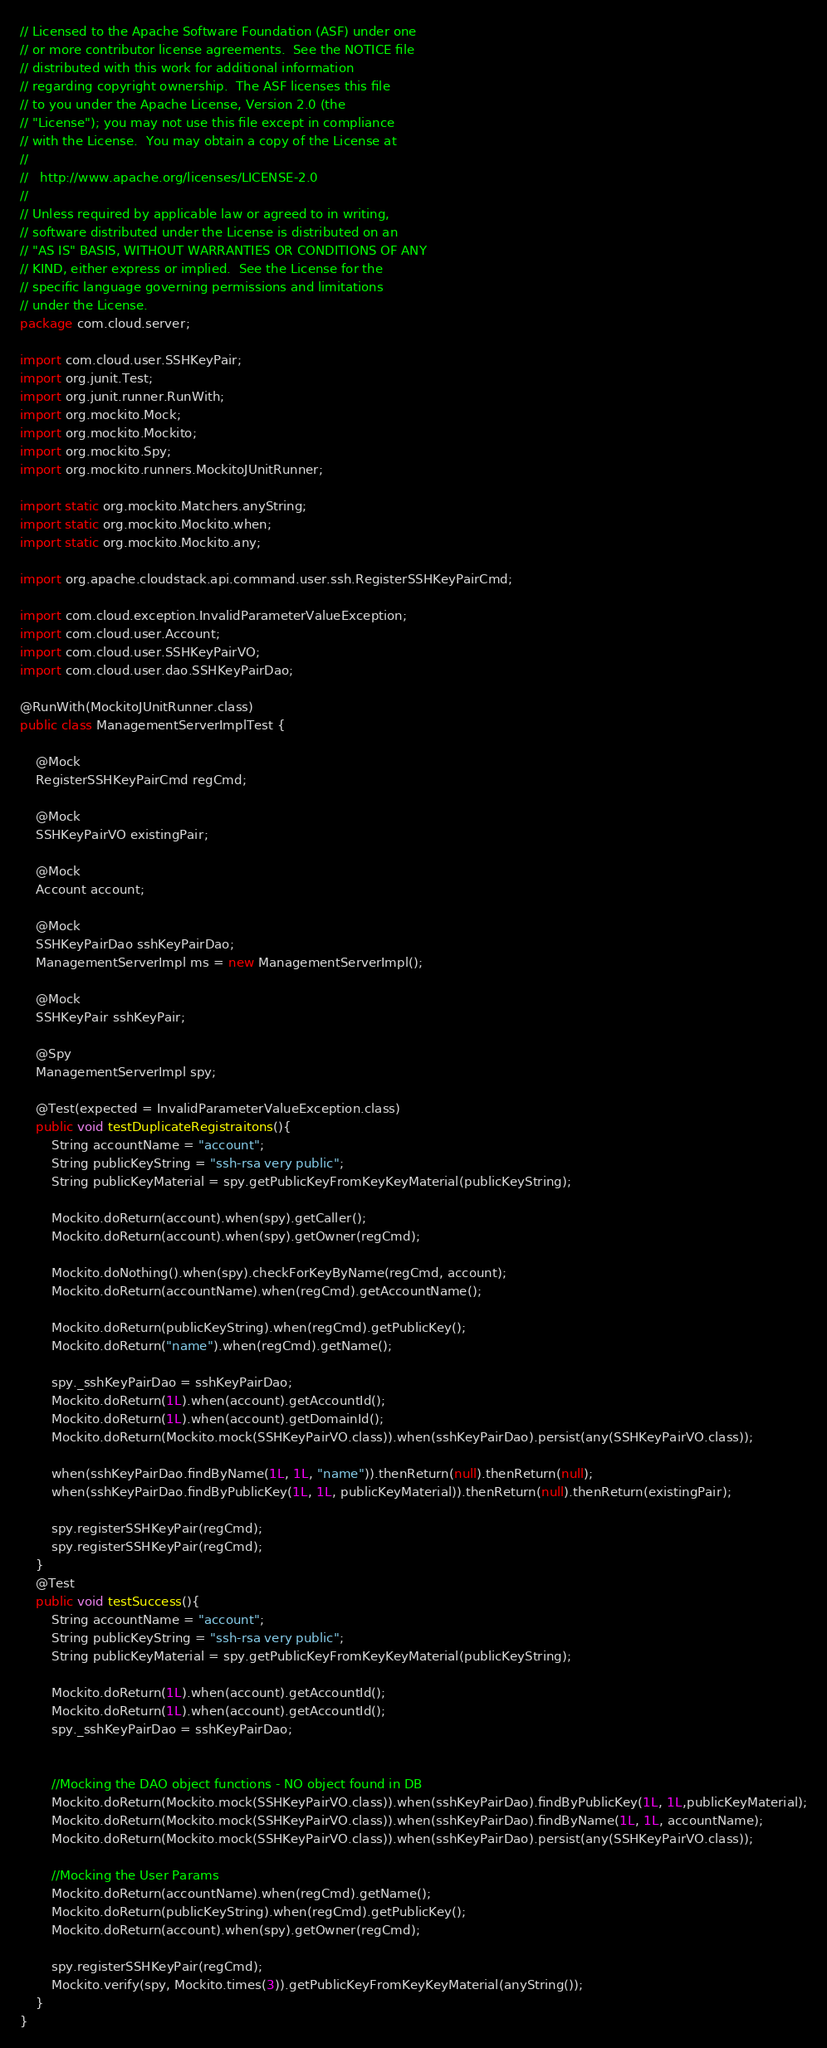Convert code to text. <code><loc_0><loc_0><loc_500><loc_500><_Java_>// Licensed to the Apache Software Foundation (ASF) under one
// or more contributor license agreements.  See the NOTICE file
// distributed with this work for additional information
// regarding copyright ownership.  The ASF licenses this file
// to you under the Apache License, Version 2.0 (the
// "License"); you may not use this file except in compliance
// with the License.  You may obtain a copy of the License at
//
//   http://www.apache.org/licenses/LICENSE-2.0
//
// Unless required by applicable law or agreed to in writing,
// software distributed under the License is distributed on an
// "AS IS" BASIS, WITHOUT WARRANTIES OR CONDITIONS OF ANY
// KIND, either express or implied.  See the License for the
// specific language governing permissions and limitations
// under the License.
package com.cloud.server;

import com.cloud.user.SSHKeyPair;
import org.junit.Test;
import org.junit.runner.RunWith;
import org.mockito.Mock;
import org.mockito.Mockito;
import org.mockito.Spy;
import org.mockito.runners.MockitoJUnitRunner;

import static org.mockito.Matchers.anyString;
import static org.mockito.Mockito.when;
import static org.mockito.Mockito.any;

import org.apache.cloudstack.api.command.user.ssh.RegisterSSHKeyPairCmd;

import com.cloud.exception.InvalidParameterValueException;
import com.cloud.user.Account;
import com.cloud.user.SSHKeyPairVO;
import com.cloud.user.dao.SSHKeyPairDao;

@RunWith(MockitoJUnitRunner.class)
public class ManagementServerImplTest {

    @Mock
    RegisterSSHKeyPairCmd regCmd;

    @Mock
    SSHKeyPairVO existingPair;

    @Mock
    Account account;

    @Mock
    SSHKeyPairDao sshKeyPairDao;
    ManagementServerImpl ms = new ManagementServerImpl();

    @Mock
    SSHKeyPair sshKeyPair;

    @Spy
    ManagementServerImpl spy;

    @Test(expected = InvalidParameterValueException.class)
    public void testDuplicateRegistraitons(){
        String accountName = "account";
        String publicKeyString = "ssh-rsa very public";
        String publicKeyMaterial = spy.getPublicKeyFromKeyKeyMaterial(publicKeyString);

        Mockito.doReturn(account).when(spy).getCaller();
        Mockito.doReturn(account).when(spy).getOwner(regCmd);

        Mockito.doNothing().when(spy).checkForKeyByName(regCmd, account);
        Mockito.doReturn(accountName).when(regCmd).getAccountName();

        Mockito.doReturn(publicKeyString).when(regCmd).getPublicKey();
        Mockito.doReturn("name").when(regCmd).getName();

        spy._sshKeyPairDao = sshKeyPairDao;
        Mockito.doReturn(1L).when(account).getAccountId();
        Mockito.doReturn(1L).when(account).getDomainId();
        Mockito.doReturn(Mockito.mock(SSHKeyPairVO.class)).when(sshKeyPairDao).persist(any(SSHKeyPairVO.class));

        when(sshKeyPairDao.findByName(1L, 1L, "name")).thenReturn(null).thenReturn(null);
        when(sshKeyPairDao.findByPublicKey(1L, 1L, publicKeyMaterial)).thenReturn(null).thenReturn(existingPair);

        spy.registerSSHKeyPair(regCmd);
        spy.registerSSHKeyPair(regCmd);
    }
    @Test
    public void testSuccess(){
        String accountName = "account";
        String publicKeyString = "ssh-rsa very public";
        String publicKeyMaterial = spy.getPublicKeyFromKeyKeyMaterial(publicKeyString);

        Mockito.doReturn(1L).when(account).getAccountId();
        Mockito.doReturn(1L).when(account).getAccountId();
        spy._sshKeyPairDao = sshKeyPairDao;


        //Mocking the DAO object functions - NO object found in DB
        Mockito.doReturn(Mockito.mock(SSHKeyPairVO.class)).when(sshKeyPairDao).findByPublicKey(1L, 1L,publicKeyMaterial);
        Mockito.doReturn(Mockito.mock(SSHKeyPairVO.class)).when(sshKeyPairDao).findByName(1L, 1L, accountName);
        Mockito.doReturn(Mockito.mock(SSHKeyPairVO.class)).when(sshKeyPairDao).persist(any(SSHKeyPairVO.class));

        //Mocking the User Params
        Mockito.doReturn(accountName).when(regCmd).getName();
        Mockito.doReturn(publicKeyString).when(regCmd).getPublicKey();
        Mockito.doReturn(account).when(spy).getOwner(regCmd);

        spy.registerSSHKeyPair(regCmd);
        Mockito.verify(spy, Mockito.times(3)).getPublicKeyFromKeyKeyMaterial(anyString());
    }
}
</code> 